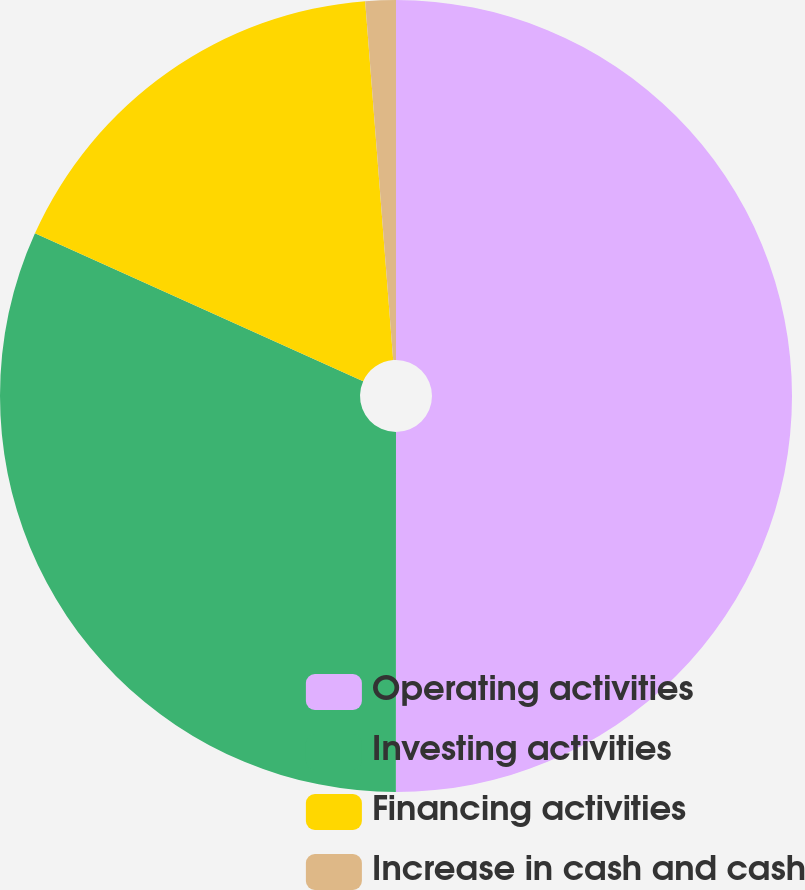<chart> <loc_0><loc_0><loc_500><loc_500><pie_chart><fcel>Operating activities<fcel>Investing activities<fcel>Financing activities<fcel>Increase in cash and cash<nl><fcel>50.0%<fcel>31.73%<fcel>17.02%<fcel>1.24%<nl></chart> 